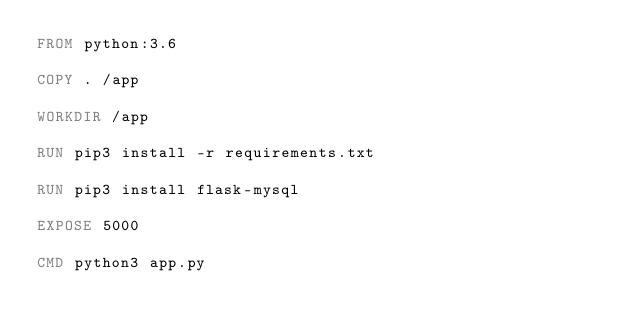<code> <loc_0><loc_0><loc_500><loc_500><_Dockerfile_>FROM python:3.6

COPY . /app

WORKDIR /app

RUN pip3 install -r requirements.txt

RUN pip3 install flask-mysql

EXPOSE 5000

CMD python3 app.py
</code> 